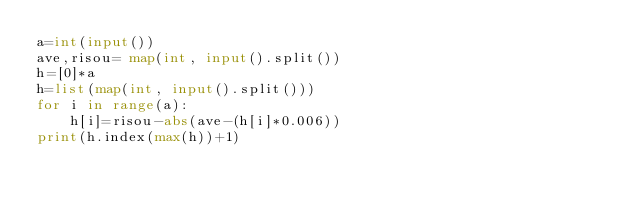Convert code to text. <code><loc_0><loc_0><loc_500><loc_500><_Python_>a=int(input())
ave,risou= map(int, input().split())
h=[0]*a
h=list(map(int, input().split()))
for i in range(a):
    h[i]=risou-abs(ave-(h[i]*0.006))
print(h.index(max(h))+1)</code> 